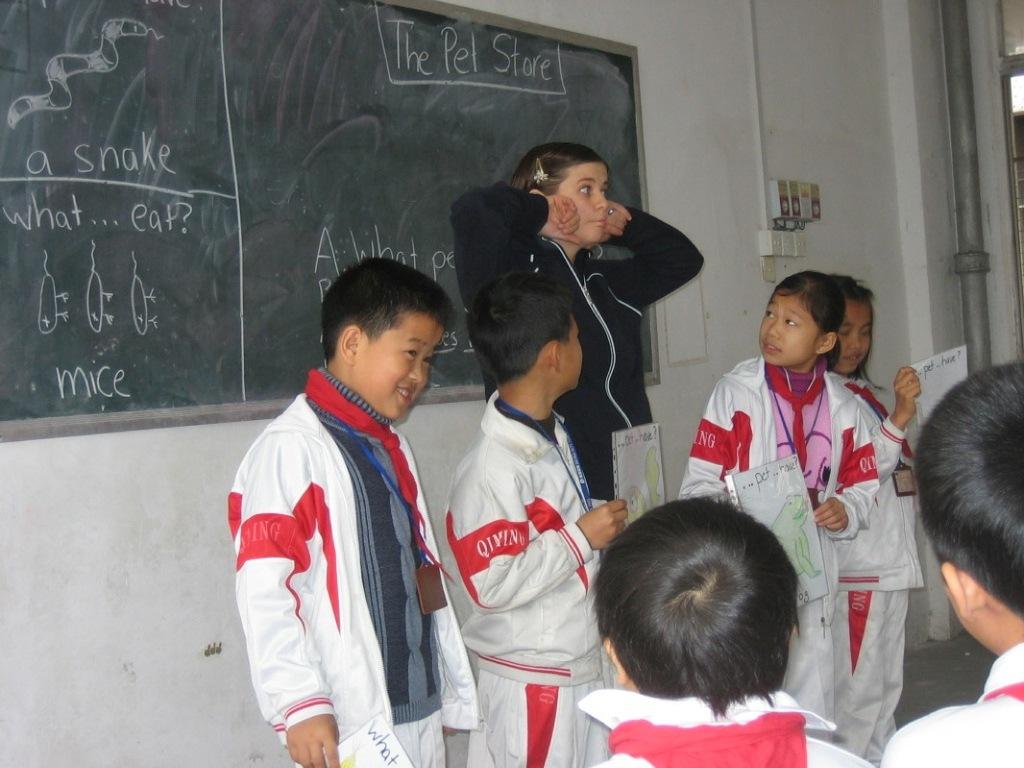What is on the board?
Provide a succinct answer. The pet store. What reptile is mentioned on theboard?
Make the answer very short. Snake. 